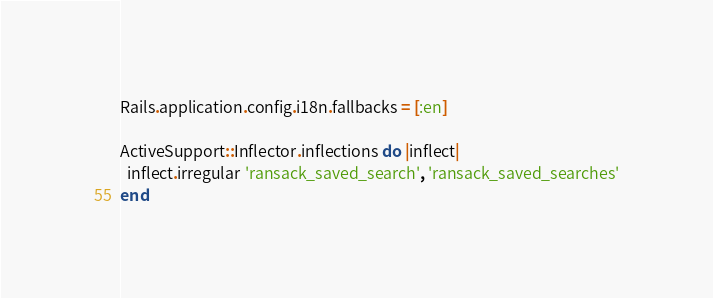Convert code to text. <code><loc_0><loc_0><loc_500><loc_500><_Ruby_>Rails.application.config.i18n.fallbacks = [:en]

ActiveSupport::Inflector.inflections do |inflect|
  inflect.irregular 'ransack_saved_search', 'ransack_saved_searches'
end</code> 